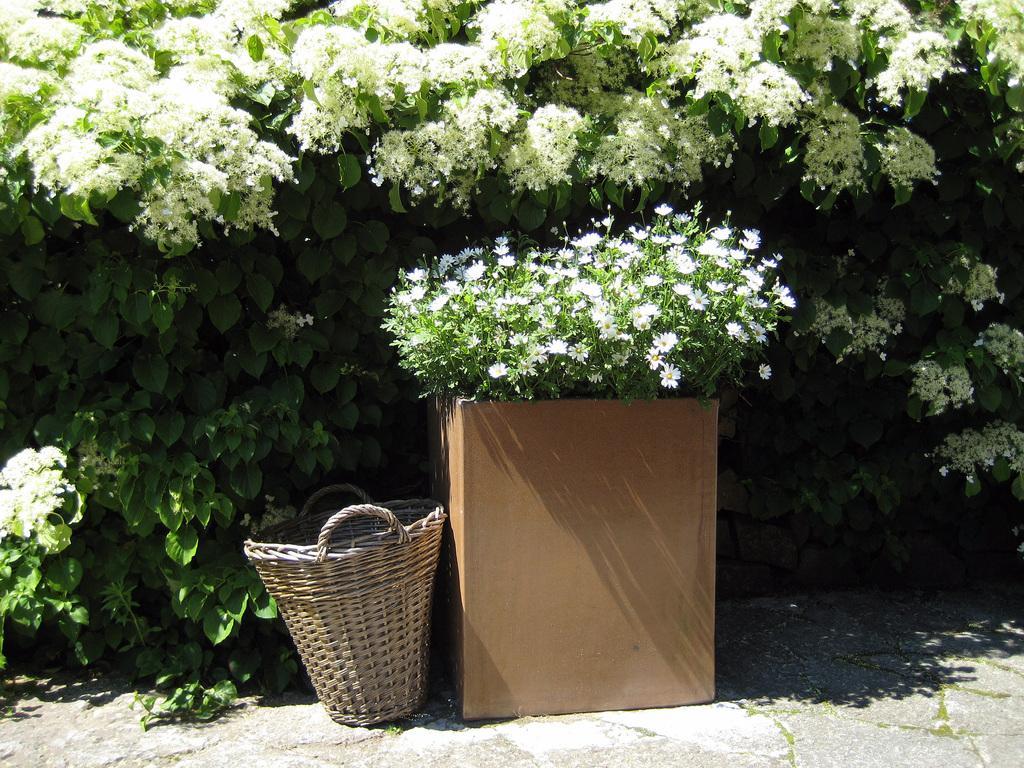In one or two sentences, can you explain what this image depicts? In this image we can see many plants. There are many flowers in the image. There is a plant pot and a basket in the image. 